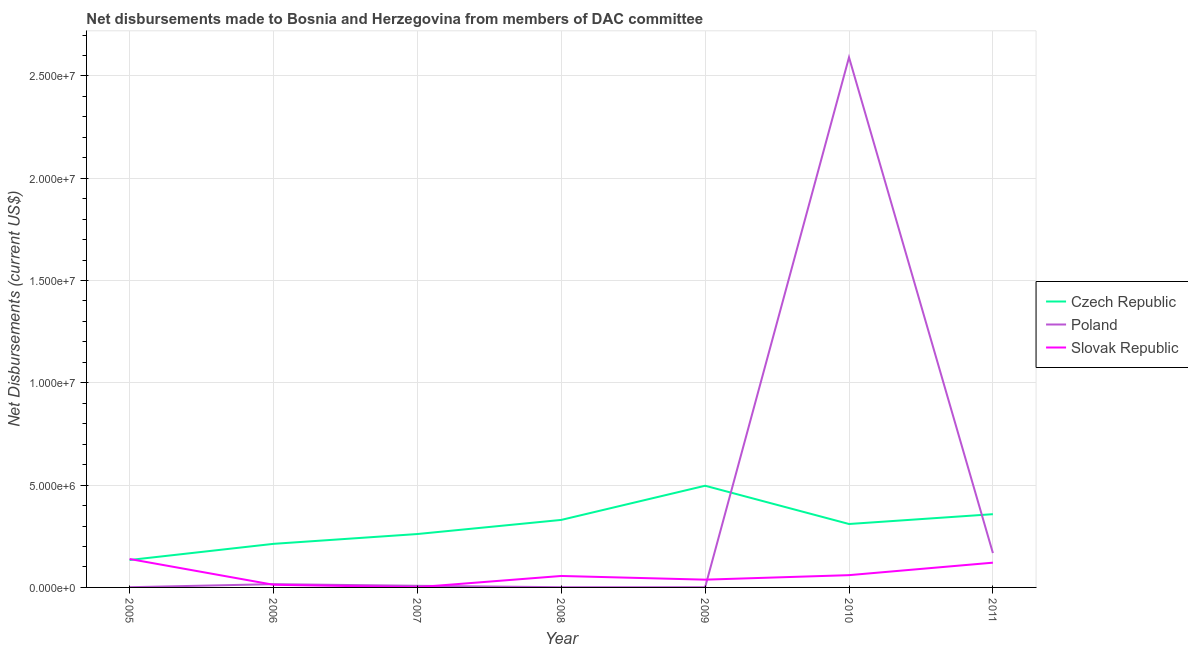Does the line corresponding to net disbursements made by slovak republic intersect with the line corresponding to net disbursements made by czech republic?
Ensure brevity in your answer.  Yes. What is the net disbursements made by poland in 2007?
Your response must be concise. 8.00e+04. Across all years, what is the maximum net disbursements made by czech republic?
Ensure brevity in your answer.  4.97e+06. Across all years, what is the minimum net disbursements made by czech republic?
Your answer should be very brief. 1.34e+06. In which year was the net disbursements made by slovak republic minimum?
Offer a terse response. 2007. What is the total net disbursements made by slovak republic in the graph?
Your answer should be compact. 4.28e+06. What is the difference between the net disbursements made by slovak republic in 2010 and that in 2011?
Keep it short and to the point. -6.10e+05. What is the difference between the net disbursements made by czech republic in 2007 and the net disbursements made by poland in 2005?
Make the answer very short. 2.60e+06. What is the average net disbursements made by slovak republic per year?
Make the answer very short. 6.11e+05. In the year 2010, what is the difference between the net disbursements made by poland and net disbursements made by slovak republic?
Offer a very short reply. 2.53e+07. Is the net disbursements made by poland in 2006 less than that in 2007?
Provide a succinct answer. No. Is the difference between the net disbursements made by czech republic in 2007 and 2009 greater than the difference between the net disbursements made by poland in 2007 and 2009?
Offer a terse response. No. What is the difference between the highest and the second highest net disbursements made by poland?
Give a very brief answer. 2.42e+07. What is the difference between the highest and the lowest net disbursements made by poland?
Offer a very short reply. 2.59e+07. How many years are there in the graph?
Make the answer very short. 7. Where does the legend appear in the graph?
Offer a very short reply. Center right. How are the legend labels stacked?
Keep it short and to the point. Vertical. What is the title of the graph?
Make the answer very short. Net disbursements made to Bosnia and Herzegovina from members of DAC committee. Does "Nuclear sources" appear as one of the legend labels in the graph?
Provide a succinct answer. No. What is the label or title of the Y-axis?
Make the answer very short. Net Disbursements (current US$). What is the Net Disbursements (current US$) in Czech Republic in 2005?
Provide a succinct answer. 1.34e+06. What is the Net Disbursements (current US$) of Poland in 2005?
Offer a terse response. 10000. What is the Net Disbursements (current US$) of Slovak Republic in 2005?
Offer a terse response. 1.39e+06. What is the Net Disbursements (current US$) in Czech Republic in 2006?
Ensure brevity in your answer.  2.13e+06. What is the Net Disbursements (current US$) in Poland in 2006?
Provide a short and direct response. 1.60e+05. What is the Net Disbursements (current US$) in Czech Republic in 2007?
Give a very brief answer. 2.61e+06. What is the Net Disbursements (current US$) of Slovak Republic in 2007?
Give a very brief answer. 10000. What is the Net Disbursements (current US$) in Czech Republic in 2008?
Your answer should be very brief. 3.30e+06. What is the Net Disbursements (current US$) of Poland in 2008?
Your answer should be very brief. 10000. What is the Net Disbursements (current US$) in Slovak Republic in 2008?
Offer a terse response. 5.60e+05. What is the Net Disbursements (current US$) of Czech Republic in 2009?
Make the answer very short. 4.97e+06. What is the Net Disbursements (current US$) in Poland in 2009?
Make the answer very short. 10000. What is the Net Disbursements (current US$) in Slovak Republic in 2009?
Your answer should be very brief. 3.80e+05. What is the Net Disbursements (current US$) of Czech Republic in 2010?
Ensure brevity in your answer.  3.10e+06. What is the Net Disbursements (current US$) of Poland in 2010?
Your answer should be compact. 2.59e+07. What is the Net Disbursements (current US$) in Slovak Republic in 2010?
Keep it short and to the point. 6.00e+05. What is the Net Disbursements (current US$) in Czech Republic in 2011?
Make the answer very short. 3.58e+06. What is the Net Disbursements (current US$) of Poland in 2011?
Offer a very short reply. 1.68e+06. What is the Net Disbursements (current US$) in Slovak Republic in 2011?
Give a very brief answer. 1.21e+06. Across all years, what is the maximum Net Disbursements (current US$) of Czech Republic?
Provide a short and direct response. 4.97e+06. Across all years, what is the maximum Net Disbursements (current US$) in Poland?
Make the answer very short. 2.59e+07. Across all years, what is the maximum Net Disbursements (current US$) in Slovak Republic?
Provide a short and direct response. 1.39e+06. Across all years, what is the minimum Net Disbursements (current US$) of Czech Republic?
Give a very brief answer. 1.34e+06. Across all years, what is the minimum Net Disbursements (current US$) in Slovak Republic?
Your response must be concise. 10000. What is the total Net Disbursements (current US$) in Czech Republic in the graph?
Ensure brevity in your answer.  2.10e+07. What is the total Net Disbursements (current US$) of Poland in the graph?
Offer a very short reply. 2.79e+07. What is the total Net Disbursements (current US$) in Slovak Republic in the graph?
Make the answer very short. 4.28e+06. What is the difference between the Net Disbursements (current US$) in Czech Republic in 2005 and that in 2006?
Provide a succinct answer. -7.90e+05. What is the difference between the Net Disbursements (current US$) in Poland in 2005 and that in 2006?
Give a very brief answer. -1.50e+05. What is the difference between the Net Disbursements (current US$) of Slovak Republic in 2005 and that in 2006?
Keep it short and to the point. 1.26e+06. What is the difference between the Net Disbursements (current US$) of Czech Republic in 2005 and that in 2007?
Your answer should be compact. -1.27e+06. What is the difference between the Net Disbursements (current US$) of Slovak Republic in 2005 and that in 2007?
Keep it short and to the point. 1.38e+06. What is the difference between the Net Disbursements (current US$) in Czech Republic in 2005 and that in 2008?
Your answer should be very brief. -1.96e+06. What is the difference between the Net Disbursements (current US$) of Slovak Republic in 2005 and that in 2008?
Provide a succinct answer. 8.30e+05. What is the difference between the Net Disbursements (current US$) in Czech Republic in 2005 and that in 2009?
Make the answer very short. -3.63e+06. What is the difference between the Net Disbursements (current US$) of Slovak Republic in 2005 and that in 2009?
Your answer should be very brief. 1.01e+06. What is the difference between the Net Disbursements (current US$) in Czech Republic in 2005 and that in 2010?
Offer a terse response. -1.76e+06. What is the difference between the Net Disbursements (current US$) in Poland in 2005 and that in 2010?
Your answer should be compact. -2.59e+07. What is the difference between the Net Disbursements (current US$) in Slovak Republic in 2005 and that in 2010?
Your answer should be compact. 7.90e+05. What is the difference between the Net Disbursements (current US$) of Czech Republic in 2005 and that in 2011?
Provide a succinct answer. -2.24e+06. What is the difference between the Net Disbursements (current US$) of Poland in 2005 and that in 2011?
Ensure brevity in your answer.  -1.67e+06. What is the difference between the Net Disbursements (current US$) of Slovak Republic in 2005 and that in 2011?
Ensure brevity in your answer.  1.80e+05. What is the difference between the Net Disbursements (current US$) in Czech Republic in 2006 and that in 2007?
Provide a succinct answer. -4.80e+05. What is the difference between the Net Disbursements (current US$) of Poland in 2006 and that in 2007?
Ensure brevity in your answer.  8.00e+04. What is the difference between the Net Disbursements (current US$) of Slovak Republic in 2006 and that in 2007?
Provide a short and direct response. 1.20e+05. What is the difference between the Net Disbursements (current US$) of Czech Republic in 2006 and that in 2008?
Make the answer very short. -1.17e+06. What is the difference between the Net Disbursements (current US$) of Slovak Republic in 2006 and that in 2008?
Give a very brief answer. -4.30e+05. What is the difference between the Net Disbursements (current US$) of Czech Republic in 2006 and that in 2009?
Provide a succinct answer. -2.84e+06. What is the difference between the Net Disbursements (current US$) in Poland in 2006 and that in 2009?
Offer a terse response. 1.50e+05. What is the difference between the Net Disbursements (current US$) in Slovak Republic in 2006 and that in 2009?
Offer a terse response. -2.50e+05. What is the difference between the Net Disbursements (current US$) in Czech Republic in 2006 and that in 2010?
Provide a short and direct response. -9.70e+05. What is the difference between the Net Disbursements (current US$) of Poland in 2006 and that in 2010?
Provide a succinct answer. -2.58e+07. What is the difference between the Net Disbursements (current US$) in Slovak Republic in 2006 and that in 2010?
Offer a terse response. -4.70e+05. What is the difference between the Net Disbursements (current US$) of Czech Republic in 2006 and that in 2011?
Provide a succinct answer. -1.45e+06. What is the difference between the Net Disbursements (current US$) in Poland in 2006 and that in 2011?
Offer a very short reply. -1.52e+06. What is the difference between the Net Disbursements (current US$) of Slovak Republic in 2006 and that in 2011?
Offer a terse response. -1.08e+06. What is the difference between the Net Disbursements (current US$) in Czech Republic in 2007 and that in 2008?
Make the answer very short. -6.90e+05. What is the difference between the Net Disbursements (current US$) in Poland in 2007 and that in 2008?
Ensure brevity in your answer.  7.00e+04. What is the difference between the Net Disbursements (current US$) in Slovak Republic in 2007 and that in 2008?
Offer a very short reply. -5.50e+05. What is the difference between the Net Disbursements (current US$) of Czech Republic in 2007 and that in 2009?
Make the answer very short. -2.36e+06. What is the difference between the Net Disbursements (current US$) in Poland in 2007 and that in 2009?
Your answer should be compact. 7.00e+04. What is the difference between the Net Disbursements (current US$) in Slovak Republic in 2007 and that in 2009?
Provide a succinct answer. -3.70e+05. What is the difference between the Net Disbursements (current US$) of Czech Republic in 2007 and that in 2010?
Keep it short and to the point. -4.90e+05. What is the difference between the Net Disbursements (current US$) of Poland in 2007 and that in 2010?
Offer a very short reply. -2.58e+07. What is the difference between the Net Disbursements (current US$) of Slovak Republic in 2007 and that in 2010?
Ensure brevity in your answer.  -5.90e+05. What is the difference between the Net Disbursements (current US$) in Czech Republic in 2007 and that in 2011?
Provide a short and direct response. -9.70e+05. What is the difference between the Net Disbursements (current US$) of Poland in 2007 and that in 2011?
Provide a succinct answer. -1.60e+06. What is the difference between the Net Disbursements (current US$) of Slovak Republic in 2007 and that in 2011?
Your answer should be very brief. -1.20e+06. What is the difference between the Net Disbursements (current US$) in Czech Republic in 2008 and that in 2009?
Offer a terse response. -1.67e+06. What is the difference between the Net Disbursements (current US$) in Poland in 2008 and that in 2009?
Keep it short and to the point. 0. What is the difference between the Net Disbursements (current US$) in Poland in 2008 and that in 2010?
Your answer should be very brief. -2.59e+07. What is the difference between the Net Disbursements (current US$) of Slovak Republic in 2008 and that in 2010?
Make the answer very short. -4.00e+04. What is the difference between the Net Disbursements (current US$) of Czech Republic in 2008 and that in 2011?
Make the answer very short. -2.80e+05. What is the difference between the Net Disbursements (current US$) of Poland in 2008 and that in 2011?
Provide a succinct answer. -1.67e+06. What is the difference between the Net Disbursements (current US$) of Slovak Republic in 2008 and that in 2011?
Make the answer very short. -6.50e+05. What is the difference between the Net Disbursements (current US$) of Czech Republic in 2009 and that in 2010?
Your response must be concise. 1.87e+06. What is the difference between the Net Disbursements (current US$) in Poland in 2009 and that in 2010?
Your answer should be compact. -2.59e+07. What is the difference between the Net Disbursements (current US$) of Slovak Republic in 2009 and that in 2010?
Your response must be concise. -2.20e+05. What is the difference between the Net Disbursements (current US$) of Czech Republic in 2009 and that in 2011?
Ensure brevity in your answer.  1.39e+06. What is the difference between the Net Disbursements (current US$) of Poland in 2009 and that in 2011?
Keep it short and to the point. -1.67e+06. What is the difference between the Net Disbursements (current US$) of Slovak Republic in 2009 and that in 2011?
Make the answer very short. -8.30e+05. What is the difference between the Net Disbursements (current US$) of Czech Republic in 2010 and that in 2011?
Make the answer very short. -4.80e+05. What is the difference between the Net Disbursements (current US$) in Poland in 2010 and that in 2011?
Your response must be concise. 2.42e+07. What is the difference between the Net Disbursements (current US$) in Slovak Republic in 2010 and that in 2011?
Your answer should be very brief. -6.10e+05. What is the difference between the Net Disbursements (current US$) in Czech Republic in 2005 and the Net Disbursements (current US$) in Poland in 2006?
Keep it short and to the point. 1.18e+06. What is the difference between the Net Disbursements (current US$) of Czech Republic in 2005 and the Net Disbursements (current US$) of Slovak Republic in 2006?
Your response must be concise. 1.21e+06. What is the difference between the Net Disbursements (current US$) of Czech Republic in 2005 and the Net Disbursements (current US$) of Poland in 2007?
Offer a very short reply. 1.26e+06. What is the difference between the Net Disbursements (current US$) of Czech Republic in 2005 and the Net Disbursements (current US$) of Slovak Republic in 2007?
Offer a very short reply. 1.33e+06. What is the difference between the Net Disbursements (current US$) in Czech Republic in 2005 and the Net Disbursements (current US$) in Poland in 2008?
Offer a terse response. 1.33e+06. What is the difference between the Net Disbursements (current US$) of Czech Republic in 2005 and the Net Disbursements (current US$) of Slovak Republic in 2008?
Your answer should be compact. 7.80e+05. What is the difference between the Net Disbursements (current US$) of Poland in 2005 and the Net Disbursements (current US$) of Slovak Republic in 2008?
Give a very brief answer. -5.50e+05. What is the difference between the Net Disbursements (current US$) in Czech Republic in 2005 and the Net Disbursements (current US$) in Poland in 2009?
Give a very brief answer. 1.33e+06. What is the difference between the Net Disbursements (current US$) of Czech Republic in 2005 and the Net Disbursements (current US$) of Slovak Republic in 2009?
Ensure brevity in your answer.  9.60e+05. What is the difference between the Net Disbursements (current US$) in Poland in 2005 and the Net Disbursements (current US$) in Slovak Republic in 2009?
Make the answer very short. -3.70e+05. What is the difference between the Net Disbursements (current US$) in Czech Republic in 2005 and the Net Disbursements (current US$) in Poland in 2010?
Your answer should be compact. -2.46e+07. What is the difference between the Net Disbursements (current US$) of Czech Republic in 2005 and the Net Disbursements (current US$) of Slovak Republic in 2010?
Offer a very short reply. 7.40e+05. What is the difference between the Net Disbursements (current US$) of Poland in 2005 and the Net Disbursements (current US$) of Slovak Republic in 2010?
Offer a terse response. -5.90e+05. What is the difference between the Net Disbursements (current US$) in Czech Republic in 2005 and the Net Disbursements (current US$) in Slovak Republic in 2011?
Give a very brief answer. 1.30e+05. What is the difference between the Net Disbursements (current US$) in Poland in 2005 and the Net Disbursements (current US$) in Slovak Republic in 2011?
Provide a succinct answer. -1.20e+06. What is the difference between the Net Disbursements (current US$) in Czech Republic in 2006 and the Net Disbursements (current US$) in Poland in 2007?
Give a very brief answer. 2.05e+06. What is the difference between the Net Disbursements (current US$) of Czech Republic in 2006 and the Net Disbursements (current US$) of Slovak Republic in 2007?
Give a very brief answer. 2.12e+06. What is the difference between the Net Disbursements (current US$) of Poland in 2006 and the Net Disbursements (current US$) of Slovak Republic in 2007?
Offer a very short reply. 1.50e+05. What is the difference between the Net Disbursements (current US$) of Czech Republic in 2006 and the Net Disbursements (current US$) of Poland in 2008?
Your response must be concise. 2.12e+06. What is the difference between the Net Disbursements (current US$) of Czech Republic in 2006 and the Net Disbursements (current US$) of Slovak Republic in 2008?
Provide a short and direct response. 1.57e+06. What is the difference between the Net Disbursements (current US$) in Poland in 2006 and the Net Disbursements (current US$) in Slovak Republic in 2008?
Provide a short and direct response. -4.00e+05. What is the difference between the Net Disbursements (current US$) in Czech Republic in 2006 and the Net Disbursements (current US$) in Poland in 2009?
Your answer should be compact. 2.12e+06. What is the difference between the Net Disbursements (current US$) in Czech Republic in 2006 and the Net Disbursements (current US$) in Slovak Republic in 2009?
Provide a succinct answer. 1.75e+06. What is the difference between the Net Disbursements (current US$) of Poland in 2006 and the Net Disbursements (current US$) of Slovak Republic in 2009?
Give a very brief answer. -2.20e+05. What is the difference between the Net Disbursements (current US$) in Czech Republic in 2006 and the Net Disbursements (current US$) in Poland in 2010?
Offer a very short reply. -2.38e+07. What is the difference between the Net Disbursements (current US$) in Czech Republic in 2006 and the Net Disbursements (current US$) in Slovak Republic in 2010?
Your response must be concise. 1.53e+06. What is the difference between the Net Disbursements (current US$) of Poland in 2006 and the Net Disbursements (current US$) of Slovak Republic in 2010?
Ensure brevity in your answer.  -4.40e+05. What is the difference between the Net Disbursements (current US$) in Czech Republic in 2006 and the Net Disbursements (current US$) in Slovak Republic in 2011?
Ensure brevity in your answer.  9.20e+05. What is the difference between the Net Disbursements (current US$) in Poland in 2006 and the Net Disbursements (current US$) in Slovak Republic in 2011?
Your answer should be compact. -1.05e+06. What is the difference between the Net Disbursements (current US$) in Czech Republic in 2007 and the Net Disbursements (current US$) in Poland in 2008?
Your answer should be very brief. 2.60e+06. What is the difference between the Net Disbursements (current US$) of Czech Republic in 2007 and the Net Disbursements (current US$) of Slovak Republic in 2008?
Your answer should be compact. 2.05e+06. What is the difference between the Net Disbursements (current US$) in Poland in 2007 and the Net Disbursements (current US$) in Slovak Republic in 2008?
Ensure brevity in your answer.  -4.80e+05. What is the difference between the Net Disbursements (current US$) in Czech Republic in 2007 and the Net Disbursements (current US$) in Poland in 2009?
Offer a terse response. 2.60e+06. What is the difference between the Net Disbursements (current US$) of Czech Republic in 2007 and the Net Disbursements (current US$) of Slovak Republic in 2009?
Your response must be concise. 2.23e+06. What is the difference between the Net Disbursements (current US$) in Poland in 2007 and the Net Disbursements (current US$) in Slovak Republic in 2009?
Give a very brief answer. -3.00e+05. What is the difference between the Net Disbursements (current US$) of Czech Republic in 2007 and the Net Disbursements (current US$) of Poland in 2010?
Provide a succinct answer. -2.33e+07. What is the difference between the Net Disbursements (current US$) in Czech Republic in 2007 and the Net Disbursements (current US$) in Slovak Republic in 2010?
Offer a terse response. 2.01e+06. What is the difference between the Net Disbursements (current US$) in Poland in 2007 and the Net Disbursements (current US$) in Slovak Republic in 2010?
Offer a terse response. -5.20e+05. What is the difference between the Net Disbursements (current US$) in Czech Republic in 2007 and the Net Disbursements (current US$) in Poland in 2011?
Make the answer very short. 9.30e+05. What is the difference between the Net Disbursements (current US$) of Czech Republic in 2007 and the Net Disbursements (current US$) of Slovak Republic in 2011?
Offer a very short reply. 1.40e+06. What is the difference between the Net Disbursements (current US$) of Poland in 2007 and the Net Disbursements (current US$) of Slovak Republic in 2011?
Make the answer very short. -1.13e+06. What is the difference between the Net Disbursements (current US$) in Czech Republic in 2008 and the Net Disbursements (current US$) in Poland in 2009?
Keep it short and to the point. 3.29e+06. What is the difference between the Net Disbursements (current US$) in Czech Republic in 2008 and the Net Disbursements (current US$) in Slovak Republic in 2009?
Keep it short and to the point. 2.92e+06. What is the difference between the Net Disbursements (current US$) of Poland in 2008 and the Net Disbursements (current US$) of Slovak Republic in 2009?
Provide a short and direct response. -3.70e+05. What is the difference between the Net Disbursements (current US$) in Czech Republic in 2008 and the Net Disbursements (current US$) in Poland in 2010?
Give a very brief answer. -2.26e+07. What is the difference between the Net Disbursements (current US$) of Czech Republic in 2008 and the Net Disbursements (current US$) of Slovak Republic in 2010?
Offer a terse response. 2.70e+06. What is the difference between the Net Disbursements (current US$) in Poland in 2008 and the Net Disbursements (current US$) in Slovak Republic in 2010?
Give a very brief answer. -5.90e+05. What is the difference between the Net Disbursements (current US$) in Czech Republic in 2008 and the Net Disbursements (current US$) in Poland in 2011?
Your answer should be compact. 1.62e+06. What is the difference between the Net Disbursements (current US$) of Czech Republic in 2008 and the Net Disbursements (current US$) of Slovak Republic in 2011?
Offer a very short reply. 2.09e+06. What is the difference between the Net Disbursements (current US$) in Poland in 2008 and the Net Disbursements (current US$) in Slovak Republic in 2011?
Provide a succinct answer. -1.20e+06. What is the difference between the Net Disbursements (current US$) of Czech Republic in 2009 and the Net Disbursements (current US$) of Poland in 2010?
Your answer should be compact. -2.09e+07. What is the difference between the Net Disbursements (current US$) of Czech Republic in 2009 and the Net Disbursements (current US$) of Slovak Republic in 2010?
Provide a short and direct response. 4.37e+06. What is the difference between the Net Disbursements (current US$) of Poland in 2009 and the Net Disbursements (current US$) of Slovak Republic in 2010?
Your answer should be compact. -5.90e+05. What is the difference between the Net Disbursements (current US$) of Czech Republic in 2009 and the Net Disbursements (current US$) of Poland in 2011?
Offer a very short reply. 3.29e+06. What is the difference between the Net Disbursements (current US$) in Czech Republic in 2009 and the Net Disbursements (current US$) in Slovak Republic in 2011?
Offer a very short reply. 3.76e+06. What is the difference between the Net Disbursements (current US$) of Poland in 2009 and the Net Disbursements (current US$) of Slovak Republic in 2011?
Provide a succinct answer. -1.20e+06. What is the difference between the Net Disbursements (current US$) in Czech Republic in 2010 and the Net Disbursements (current US$) in Poland in 2011?
Provide a short and direct response. 1.42e+06. What is the difference between the Net Disbursements (current US$) of Czech Republic in 2010 and the Net Disbursements (current US$) of Slovak Republic in 2011?
Make the answer very short. 1.89e+06. What is the difference between the Net Disbursements (current US$) of Poland in 2010 and the Net Disbursements (current US$) of Slovak Republic in 2011?
Your answer should be compact. 2.47e+07. What is the average Net Disbursements (current US$) of Czech Republic per year?
Keep it short and to the point. 3.00e+06. What is the average Net Disbursements (current US$) of Poland per year?
Your answer should be very brief. 3.98e+06. What is the average Net Disbursements (current US$) of Slovak Republic per year?
Make the answer very short. 6.11e+05. In the year 2005, what is the difference between the Net Disbursements (current US$) in Czech Republic and Net Disbursements (current US$) in Poland?
Offer a terse response. 1.33e+06. In the year 2005, what is the difference between the Net Disbursements (current US$) of Poland and Net Disbursements (current US$) of Slovak Republic?
Offer a terse response. -1.38e+06. In the year 2006, what is the difference between the Net Disbursements (current US$) in Czech Republic and Net Disbursements (current US$) in Poland?
Keep it short and to the point. 1.97e+06. In the year 2006, what is the difference between the Net Disbursements (current US$) in Czech Republic and Net Disbursements (current US$) in Slovak Republic?
Your answer should be compact. 2.00e+06. In the year 2007, what is the difference between the Net Disbursements (current US$) in Czech Republic and Net Disbursements (current US$) in Poland?
Your response must be concise. 2.53e+06. In the year 2007, what is the difference between the Net Disbursements (current US$) in Czech Republic and Net Disbursements (current US$) in Slovak Republic?
Your answer should be compact. 2.60e+06. In the year 2008, what is the difference between the Net Disbursements (current US$) in Czech Republic and Net Disbursements (current US$) in Poland?
Offer a very short reply. 3.29e+06. In the year 2008, what is the difference between the Net Disbursements (current US$) in Czech Republic and Net Disbursements (current US$) in Slovak Republic?
Provide a short and direct response. 2.74e+06. In the year 2008, what is the difference between the Net Disbursements (current US$) in Poland and Net Disbursements (current US$) in Slovak Republic?
Make the answer very short. -5.50e+05. In the year 2009, what is the difference between the Net Disbursements (current US$) of Czech Republic and Net Disbursements (current US$) of Poland?
Make the answer very short. 4.96e+06. In the year 2009, what is the difference between the Net Disbursements (current US$) of Czech Republic and Net Disbursements (current US$) of Slovak Republic?
Provide a short and direct response. 4.59e+06. In the year 2009, what is the difference between the Net Disbursements (current US$) in Poland and Net Disbursements (current US$) in Slovak Republic?
Provide a short and direct response. -3.70e+05. In the year 2010, what is the difference between the Net Disbursements (current US$) of Czech Republic and Net Disbursements (current US$) of Poland?
Ensure brevity in your answer.  -2.28e+07. In the year 2010, what is the difference between the Net Disbursements (current US$) in Czech Republic and Net Disbursements (current US$) in Slovak Republic?
Provide a short and direct response. 2.50e+06. In the year 2010, what is the difference between the Net Disbursements (current US$) of Poland and Net Disbursements (current US$) of Slovak Republic?
Provide a succinct answer. 2.53e+07. In the year 2011, what is the difference between the Net Disbursements (current US$) of Czech Republic and Net Disbursements (current US$) of Poland?
Ensure brevity in your answer.  1.90e+06. In the year 2011, what is the difference between the Net Disbursements (current US$) of Czech Republic and Net Disbursements (current US$) of Slovak Republic?
Ensure brevity in your answer.  2.37e+06. What is the ratio of the Net Disbursements (current US$) in Czech Republic in 2005 to that in 2006?
Provide a succinct answer. 0.63. What is the ratio of the Net Disbursements (current US$) in Poland in 2005 to that in 2006?
Give a very brief answer. 0.06. What is the ratio of the Net Disbursements (current US$) of Slovak Republic in 2005 to that in 2006?
Make the answer very short. 10.69. What is the ratio of the Net Disbursements (current US$) of Czech Republic in 2005 to that in 2007?
Make the answer very short. 0.51. What is the ratio of the Net Disbursements (current US$) in Slovak Republic in 2005 to that in 2007?
Offer a terse response. 139. What is the ratio of the Net Disbursements (current US$) of Czech Republic in 2005 to that in 2008?
Your response must be concise. 0.41. What is the ratio of the Net Disbursements (current US$) in Poland in 2005 to that in 2008?
Provide a short and direct response. 1. What is the ratio of the Net Disbursements (current US$) of Slovak Republic in 2005 to that in 2008?
Provide a short and direct response. 2.48. What is the ratio of the Net Disbursements (current US$) in Czech Republic in 2005 to that in 2009?
Provide a succinct answer. 0.27. What is the ratio of the Net Disbursements (current US$) in Slovak Republic in 2005 to that in 2009?
Your answer should be very brief. 3.66. What is the ratio of the Net Disbursements (current US$) of Czech Republic in 2005 to that in 2010?
Offer a terse response. 0.43. What is the ratio of the Net Disbursements (current US$) in Slovak Republic in 2005 to that in 2010?
Your answer should be very brief. 2.32. What is the ratio of the Net Disbursements (current US$) of Czech Republic in 2005 to that in 2011?
Make the answer very short. 0.37. What is the ratio of the Net Disbursements (current US$) of Poland in 2005 to that in 2011?
Provide a succinct answer. 0.01. What is the ratio of the Net Disbursements (current US$) of Slovak Republic in 2005 to that in 2011?
Offer a very short reply. 1.15. What is the ratio of the Net Disbursements (current US$) of Czech Republic in 2006 to that in 2007?
Keep it short and to the point. 0.82. What is the ratio of the Net Disbursements (current US$) of Czech Republic in 2006 to that in 2008?
Your answer should be compact. 0.65. What is the ratio of the Net Disbursements (current US$) of Poland in 2006 to that in 2008?
Your answer should be compact. 16. What is the ratio of the Net Disbursements (current US$) in Slovak Republic in 2006 to that in 2008?
Ensure brevity in your answer.  0.23. What is the ratio of the Net Disbursements (current US$) of Czech Republic in 2006 to that in 2009?
Ensure brevity in your answer.  0.43. What is the ratio of the Net Disbursements (current US$) in Slovak Republic in 2006 to that in 2009?
Offer a very short reply. 0.34. What is the ratio of the Net Disbursements (current US$) of Czech Republic in 2006 to that in 2010?
Give a very brief answer. 0.69. What is the ratio of the Net Disbursements (current US$) in Poland in 2006 to that in 2010?
Keep it short and to the point. 0.01. What is the ratio of the Net Disbursements (current US$) in Slovak Republic in 2006 to that in 2010?
Ensure brevity in your answer.  0.22. What is the ratio of the Net Disbursements (current US$) of Czech Republic in 2006 to that in 2011?
Keep it short and to the point. 0.59. What is the ratio of the Net Disbursements (current US$) in Poland in 2006 to that in 2011?
Your answer should be compact. 0.1. What is the ratio of the Net Disbursements (current US$) of Slovak Republic in 2006 to that in 2011?
Your answer should be compact. 0.11. What is the ratio of the Net Disbursements (current US$) of Czech Republic in 2007 to that in 2008?
Provide a short and direct response. 0.79. What is the ratio of the Net Disbursements (current US$) in Poland in 2007 to that in 2008?
Your answer should be compact. 8. What is the ratio of the Net Disbursements (current US$) of Slovak Republic in 2007 to that in 2008?
Ensure brevity in your answer.  0.02. What is the ratio of the Net Disbursements (current US$) of Czech Republic in 2007 to that in 2009?
Provide a short and direct response. 0.53. What is the ratio of the Net Disbursements (current US$) in Slovak Republic in 2007 to that in 2009?
Keep it short and to the point. 0.03. What is the ratio of the Net Disbursements (current US$) of Czech Republic in 2007 to that in 2010?
Provide a short and direct response. 0.84. What is the ratio of the Net Disbursements (current US$) in Poland in 2007 to that in 2010?
Your response must be concise. 0. What is the ratio of the Net Disbursements (current US$) of Slovak Republic in 2007 to that in 2010?
Your answer should be very brief. 0.02. What is the ratio of the Net Disbursements (current US$) in Czech Republic in 2007 to that in 2011?
Your answer should be compact. 0.73. What is the ratio of the Net Disbursements (current US$) of Poland in 2007 to that in 2011?
Keep it short and to the point. 0.05. What is the ratio of the Net Disbursements (current US$) in Slovak Republic in 2007 to that in 2011?
Make the answer very short. 0.01. What is the ratio of the Net Disbursements (current US$) of Czech Republic in 2008 to that in 2009?
Your answer should be compact. 0.66. What is the ratio of the Net Disbursements (current US$) in Poland in 2008 to that in 2009?
Your answer should be very brief. 1. What is the ratio of the Net Disbursements (current US$) in Slovak Republic in 2008 to that in 2009?
Provide a short and direct response. 1.47. What is the ratio of the Net Disbursements (current US$) in Czech Republic in 2008 to that in 2010?
Your answer should be compact. 1.06. What is the ratio of the Net Disbursements (current US$) of Slovak Republic in 2008 to that in 2010?
Provide a short and direct response. 0.93. What is the ratio of the Net Disbursements (current US$) in Czech Republic in 2008 to that in 2011?
Ensure brevity in your answer.  0.92. What is the ratio of the Net Disbursements (current US$) of Poland in 2008 to that in 2011?
Offer a very short reply. 0.01. What is the ratio of the Net Disbursements (current US$) of Slovak Republic in 2008 to that in 2011?
Provide a short and direct response. 0.46. What is the ratio of the Net Disbursements (current US$) in Czech Republic in 2009 to that in 2010?
Offer a terse response. 1.6. What is the ratio of the Net Disbursements (current US$) of Slovak Republic in 2009 to that in 2010?
Make the answer very short. 0.63. What is the ratio of the Net Disbursements (current US$) in Czech Republic in 2009 to that in 2011?
Provide a short and direct response. 1.39. What is the ratio of the Net Disbursements (current US$) of Poland in 2009 to that in 2011?
Provide a succinct answer. 0.01. What is the ratio of the Net Disbursements (current US$) of Slovak Republic in 2009 to that in 2011?
Offer a very short reply. 0.31. What is the ratio of the Net Disbursements (current US$) in Czech Republic in 2010 to that in 2011?
Your answer should be very brief. 0.87. What is the ratio of the Net Disbursements (current US$) in Poland in 2010 to that in 2011?
Provide a succinct answer. 15.42. What is the ratio of the Net Disbursements (current US$) of Slovak Republic in 2010 to that in 2011?
Your response must be concise. 0.5. What is the difference between the highest and the second highest Net Disbursements (current US$) of Czech Republic?
Keep it short and to the point. 1.39e+06. What is the difference between the highest and the second highest Net Disbursements (current US$) of Poland?
Make the answer very short. 2.42e+07. What is the difference between the highest and the lowest Net Disbursements (current US$) in Czech Republic?
Provide a succinct answer. 3.63e+06. What is the difference between the highest and the lowest Net Disbursements (current US$) in Poland?
Your answer should be compact. 2.59e+07. What is the difference between the highest and the lowest Net Disbursements (current US$) in Slovak Republic?
Your response must be concise. 1.38e+06. 